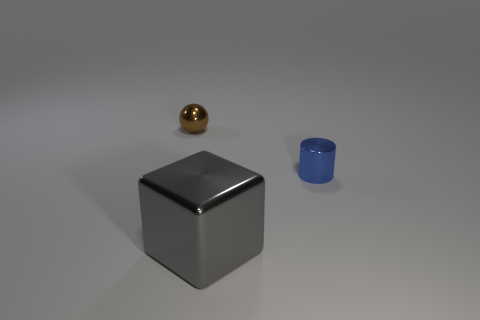Add 2 brown metal things. How many objects exist? 5 Subtract 1 cubes. How many cubes are left? 0 Subtract all spheres. How many objects are left? 2 Subtract all gray spheres. How many red blocks are left? 0 Subtract all tiny blue cylinders. Subtract all big gray rubber things. How many objects are left? 2 Add 1 small brown balls. How many small brown balls are left? 2 Add 2 yellow metal cylinders. How many yellow metal cylinders exist? 2 Subtract 0 red cubes. How many objects are left? 3 Subtract all cyan cylinders. Subtract all yellow blocks. How many cylinders are left? 1 